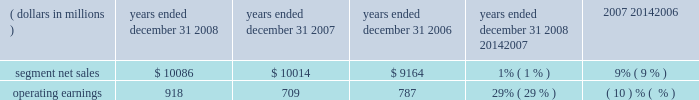Products and software , as well as ongoing investment in next-generation technologies , partially offset by savings from cost-reduction initiatives .
Reorganization of business charges increased due to employee severance costs and expenses related to the exit of a facility .
Sg&a expenses decreased , primarily due to lower marketing expenses and savings from cost-reduction initiatives , partially offset by increased expenditures on information technology upgrades .
As a percentage of net sales in 2007 as compared to 2006 , gross margin and operating margin decreased , and sg&a expenses and r&d expenditures increased .
The segment 2019s backlog was $ 647 million at december 31 , 2007 , compared to $ 1.4 billion at december 31 , 2006 .
This decrease in backlog was primarily due to a decline in customer demand driven by the segment 2019s limited product portfolio .
The segment shipped 159.1 million units in 2007 , a 27% ( 27 % ) decrease compared to shipments of 217.4 million units in 2006 .
The overall decrease reflects decreased unit shipments of products for all technologies .
For the full year 2007 , unit shipments : ( i ) decreased substantially in asia and emea , ( ii ) decreased in north america , and ( iii ) increased in latin america .
Although unit shipments by the segment decreased in 2007 , total unit shipments in the worldwide handset market increased by approximately 16% ( 16 % ) .
The segment estimates its worldwide market share was approximately 14% ( 14 % ) for the full year 2007 , a decrease of approximately 8 percentage points versus full year 2006 .
In 2007 , asp decreased approximately 9% ( 9 % ) compared to 2006 .
The overall decrease in asp was driven primarily by changes in the product-tier and geographic mix of sales .
By comparison , asp decreased approximately 11% ( 11 % ) in 2006 and 10% ( 10 % ) in 2005 .
The segment has several large customers located throughout the world .
In 2007 , aggregate net sales to the segment 2019s five largest customers accounted for approximately 42% ( 42 % ) of the segment 2019s net sales .
Besides selling directly to carriers and operators , the segment also sells products through a variety of third-party distributors and retailers , which account for approximately 33% ( 33 % ) of the segment 2019s net sales .
The largest of these distributors was brightstar corporation .
Although the u.s .
Market continued to be the segment 2019s largest individual market , many of our customers , and more than 54% ( 54 % ) of our segment 2019s 2007 net sales , were outside the u.s .
The largest of these international markets were brazil , china and mexico .
Home and networks mobility segment the home and networks mobility segment designs , manufactures , sells , installs and services : ( i ) digital video , internet protocol video and broadcast network interactive set-tops , end-to-end video delivery systems , broadband access infrastructure platforms , and associated data and voice customer premise equipment to cable television and telecom service providers ( collectively , referred to as the 201chome business 201d ) , and ( ii ) wireless access systems , including cellular infrastructure systems and wireless broadband systems , to wireless service providers ( collectively , referred to as the 201cnetwork business 201d ) .
In 2008 , the segment 2019s net sales represented 33% ( 33 % ) of the company 2019s consolidated net sales , compared to 27% ( 27 % ) in 2007 and 21% ( 21 % ) in 2006 .
( dollars in millions ) 2008 2007 2006 2008 20142007 2007 20142006 years ended december 31 percent change .
Segment results 20142008 compared to 2007 in 2008 , the segment 2019s net sales increased 1% ( 1 % ) to $ 10.1 billion , compared to $ 10.0 billion in 2007 .
The 1% ( 1 % ) increase in net sales primarily reflects a 16% ( 16 % ) increase in net sales in the home business , partially offset by an 11% ( 11 % ) decrease in net sales in the networks business .
The 16% ( 16 % ) increase in net sales in the home business is primarily driven by a 17% ( 17 % ) increase in net sales of digital entertainment devices , reflecting a 19% ( 19 % ) increase in unit shipments to 18.0 million units , partially offset by lower asp due to product mix shift and pricing pressure .
The 11% ( 11 % ) decrease in net sales in the networks business was primarily driven by : ( i ) the absence of net sales by the embedded communication computing group ( 201cecc 201d ) that was divested at the end of 2007 , and ( ii ) lower net sales of iden , gsm and cdma infrastructure equipment , partially offset by higher net sales of umts infrastructure equipment .
On a geographic basis , the 1% ( 1 % ) increase in net sales was primarily driven by higher net sales in latin america and asia , partially offset by lower net sales in north america .
The increase in net sales in latin america was 63management 2019s discussion and analysis of financial condition and results of operations %%transmsg*** transmitting job : c49054 pcn : 066000000 ***%%pcmsg|63 |00024|yes|no|02/24/2009 12:31|0|0|page is valid , no graphics -- color : n| .
What was the average segment net sales from 2006 to 2008? 
Computations: ((10086 + (10086 + 10014)) / 3)
Answer: 10062.0. 